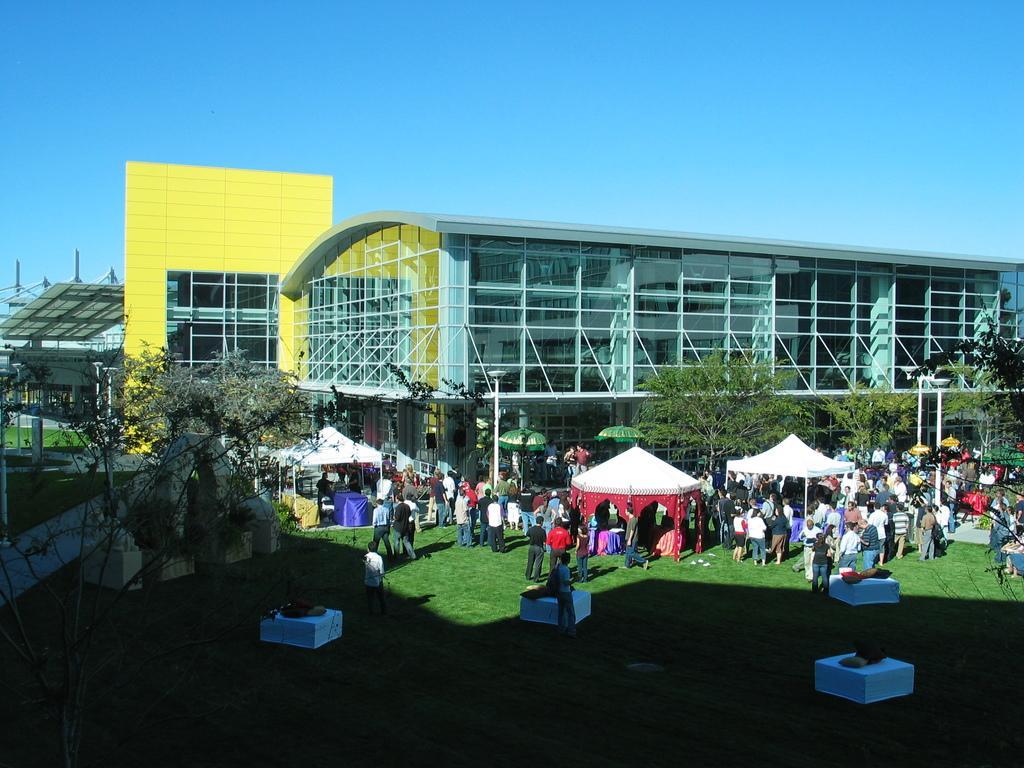Can you describe this image briefly? In this picture we can see buildings, trees, some tents and we can see some people are on the grass. 